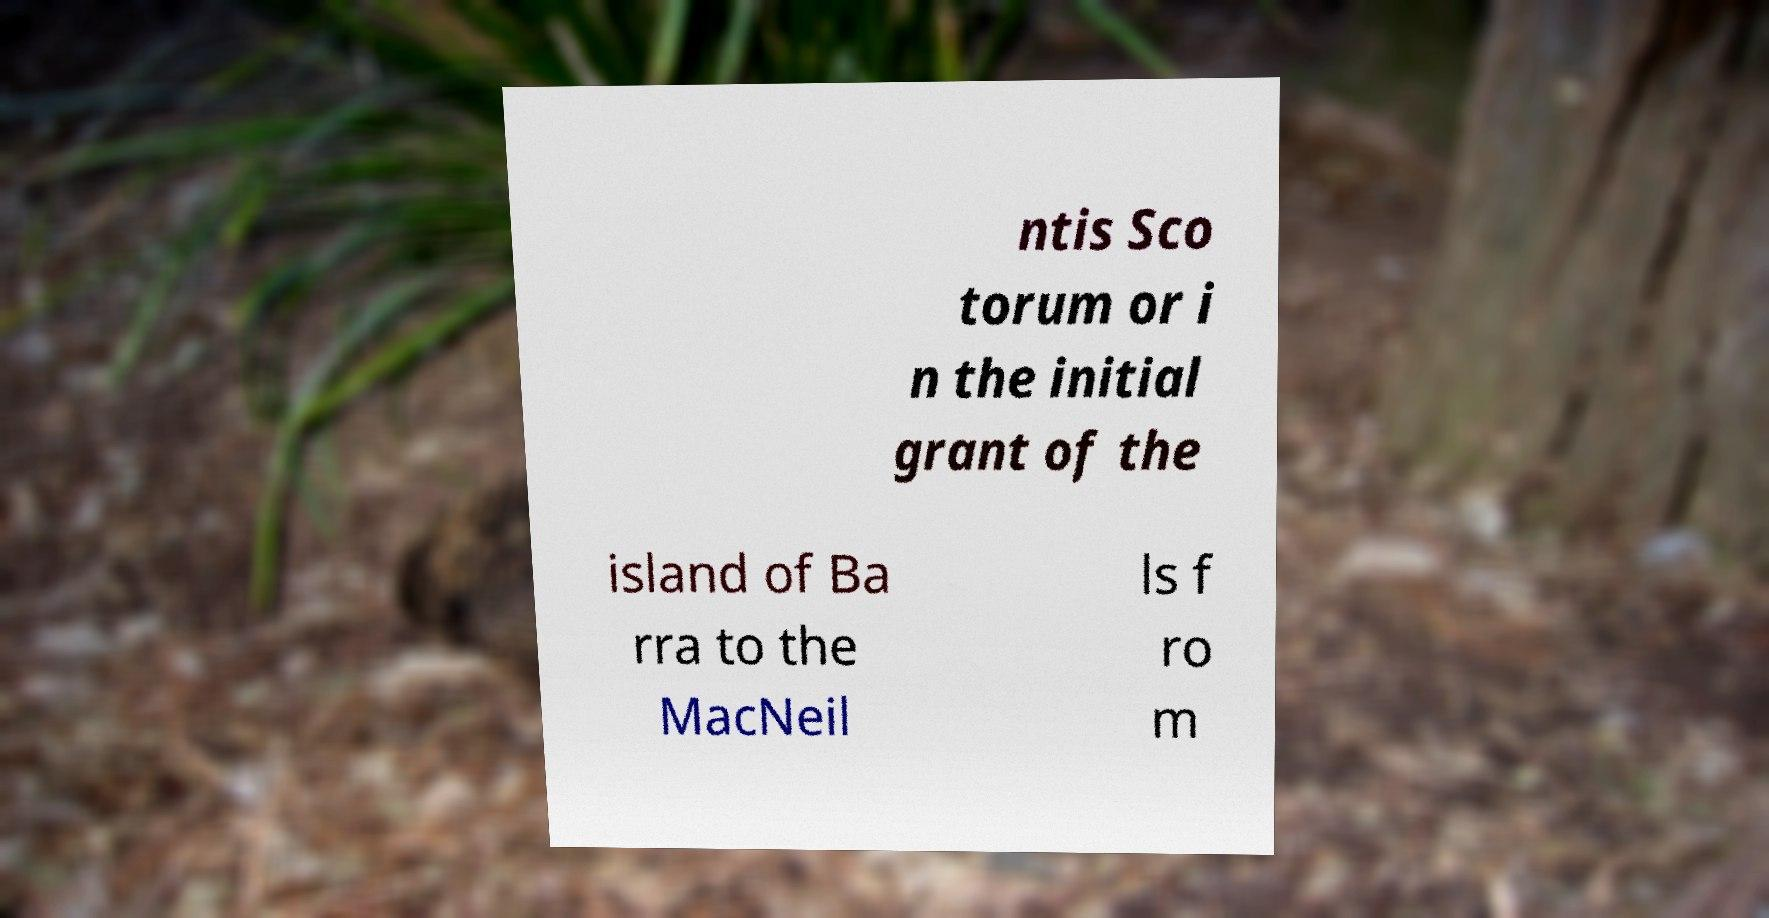Please read and relay the text visible in this image. What does it say? ntis Sco torum or i n the initial grant of the island of Ba rra to the MacNeil ls f ro m 